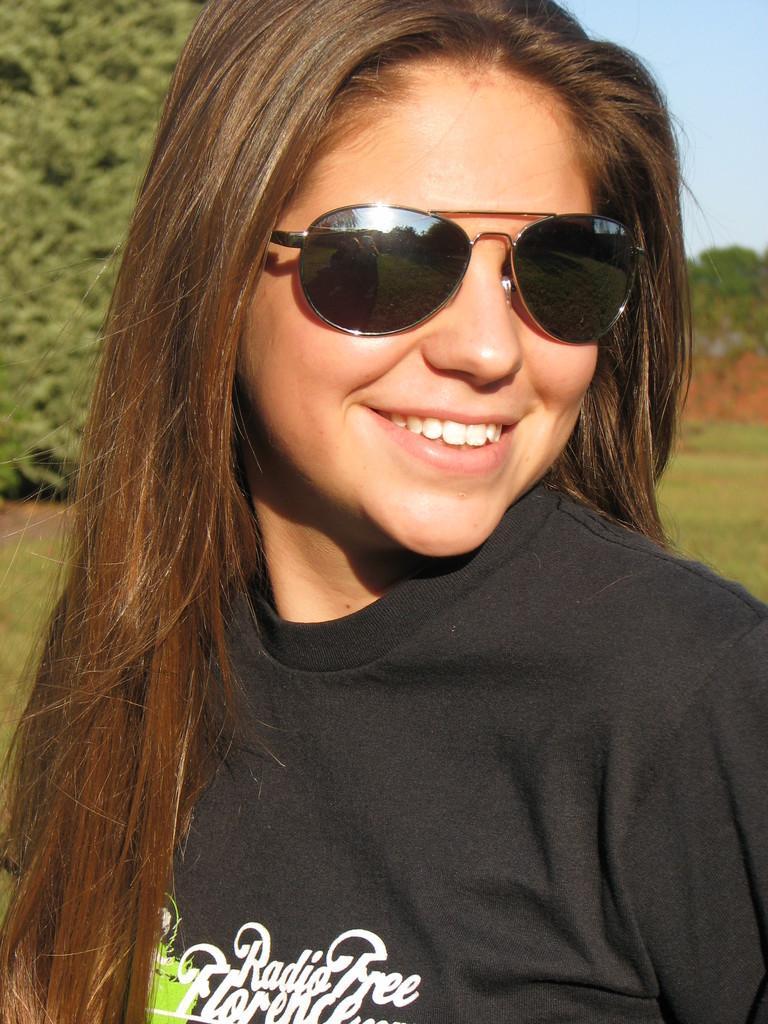Describe this image in one or two sentences. In this image I can see the person and the person is wearing black color shirt. In the background I can see few trees in green color and the sky is in blue color. 